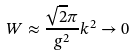Convert formula to latex. <formula><loc_0><loc_0><loc_500><loc_500>W \approx \frac { \sqrt { 2 } \pi } { g ^ { 2 } } k ^ { 2 } \rightarrow 0</formula> 